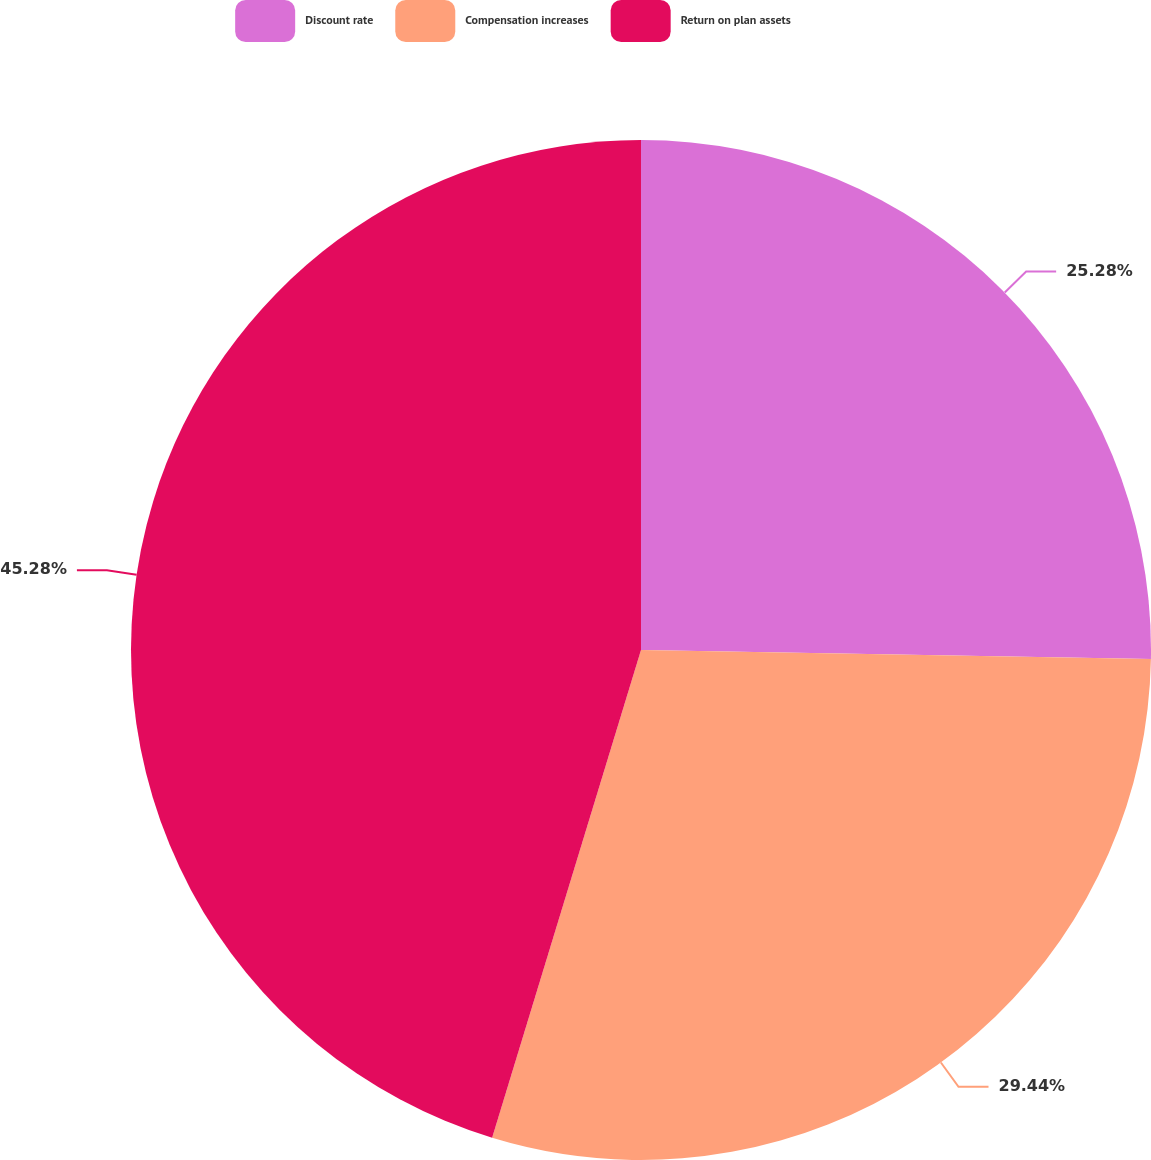Convert chart to OTSL. <chart><loc_0><loc_0><loc_500><loc_500><pie_chart><fcel>Discount rate<fcel>Compensation increases<fcel>Return on plan assets<nl><fcel>25.28%<fcel>29.44%<fcel>45.29%<nl></chart> 